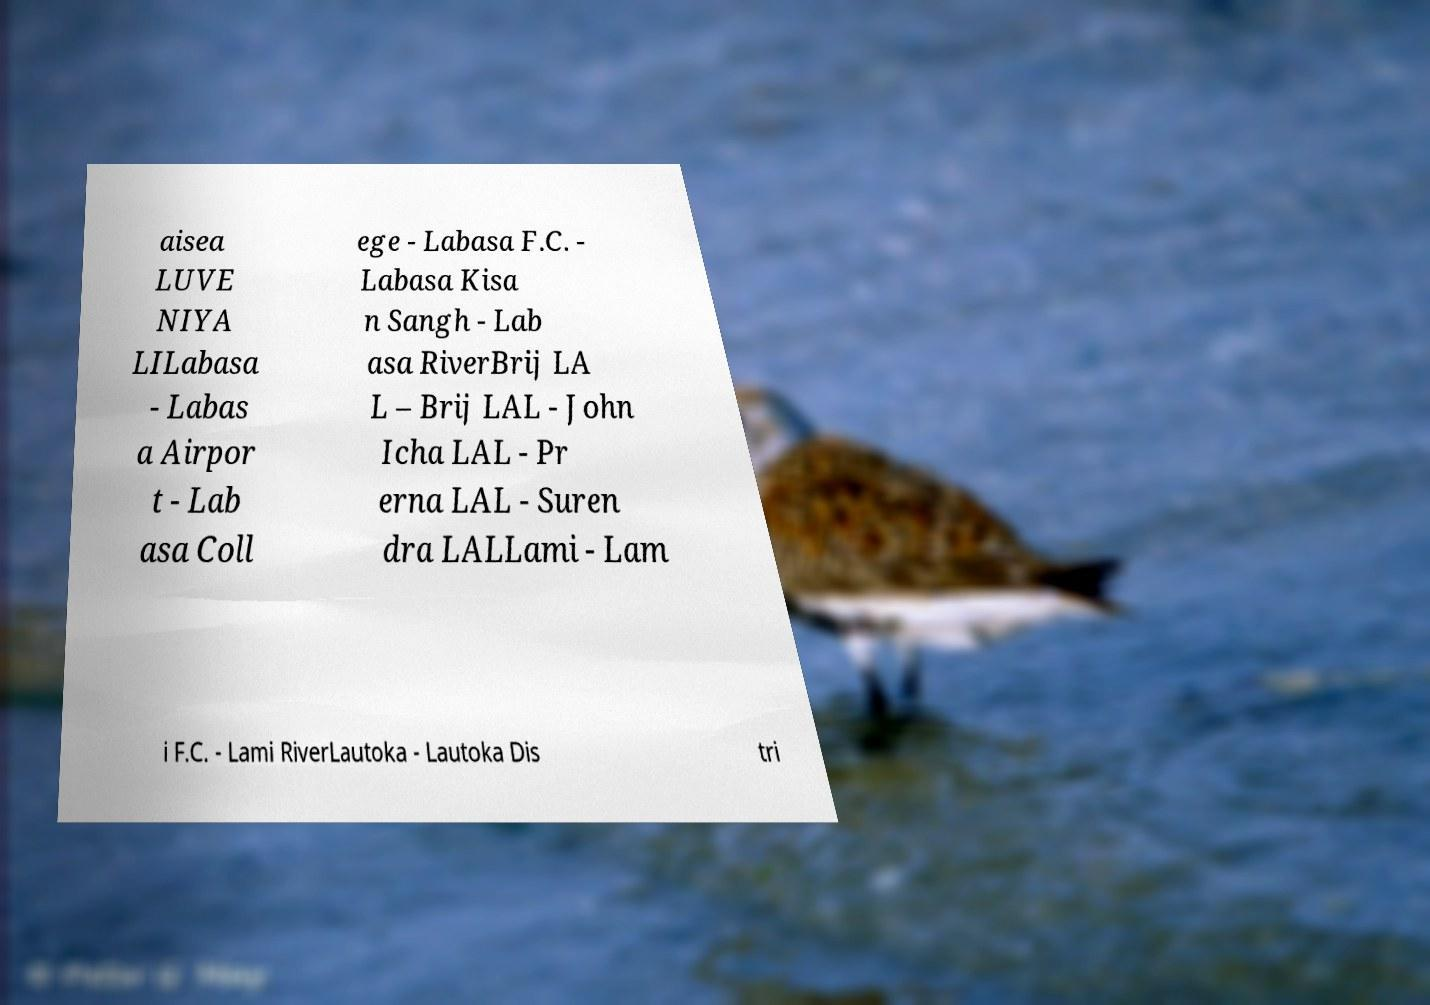Could you extract and type out the text from this image? aisea LUVE NIYA LILabasa - Labas a Airpor t - Lab asa Coll ege - Labasa F.C. - Labasa Kisa n Sangh - Lab asa RiverBrij LA L – Brij LAL - John Icha LAL - Pr erna LAL - Suren dra LALLami - Lam i F.C. - Lami RiverLautoka - Lautoka Dis tri 